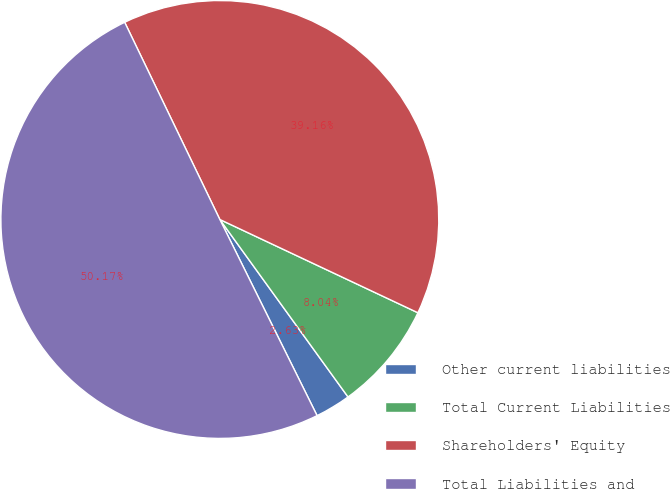<chart> <loc_0><loc_0><loc_500><loc_500><pie_chart><fcel>Other current liabilities<fcel>Total Current Liabilities<fcel>Shareholders' Equity<fcel>Total Liabilities and<nl><fcel>2.63%<fcel>8.04%<fcel>39.16%<fcel>50.17%<nl></chart> 